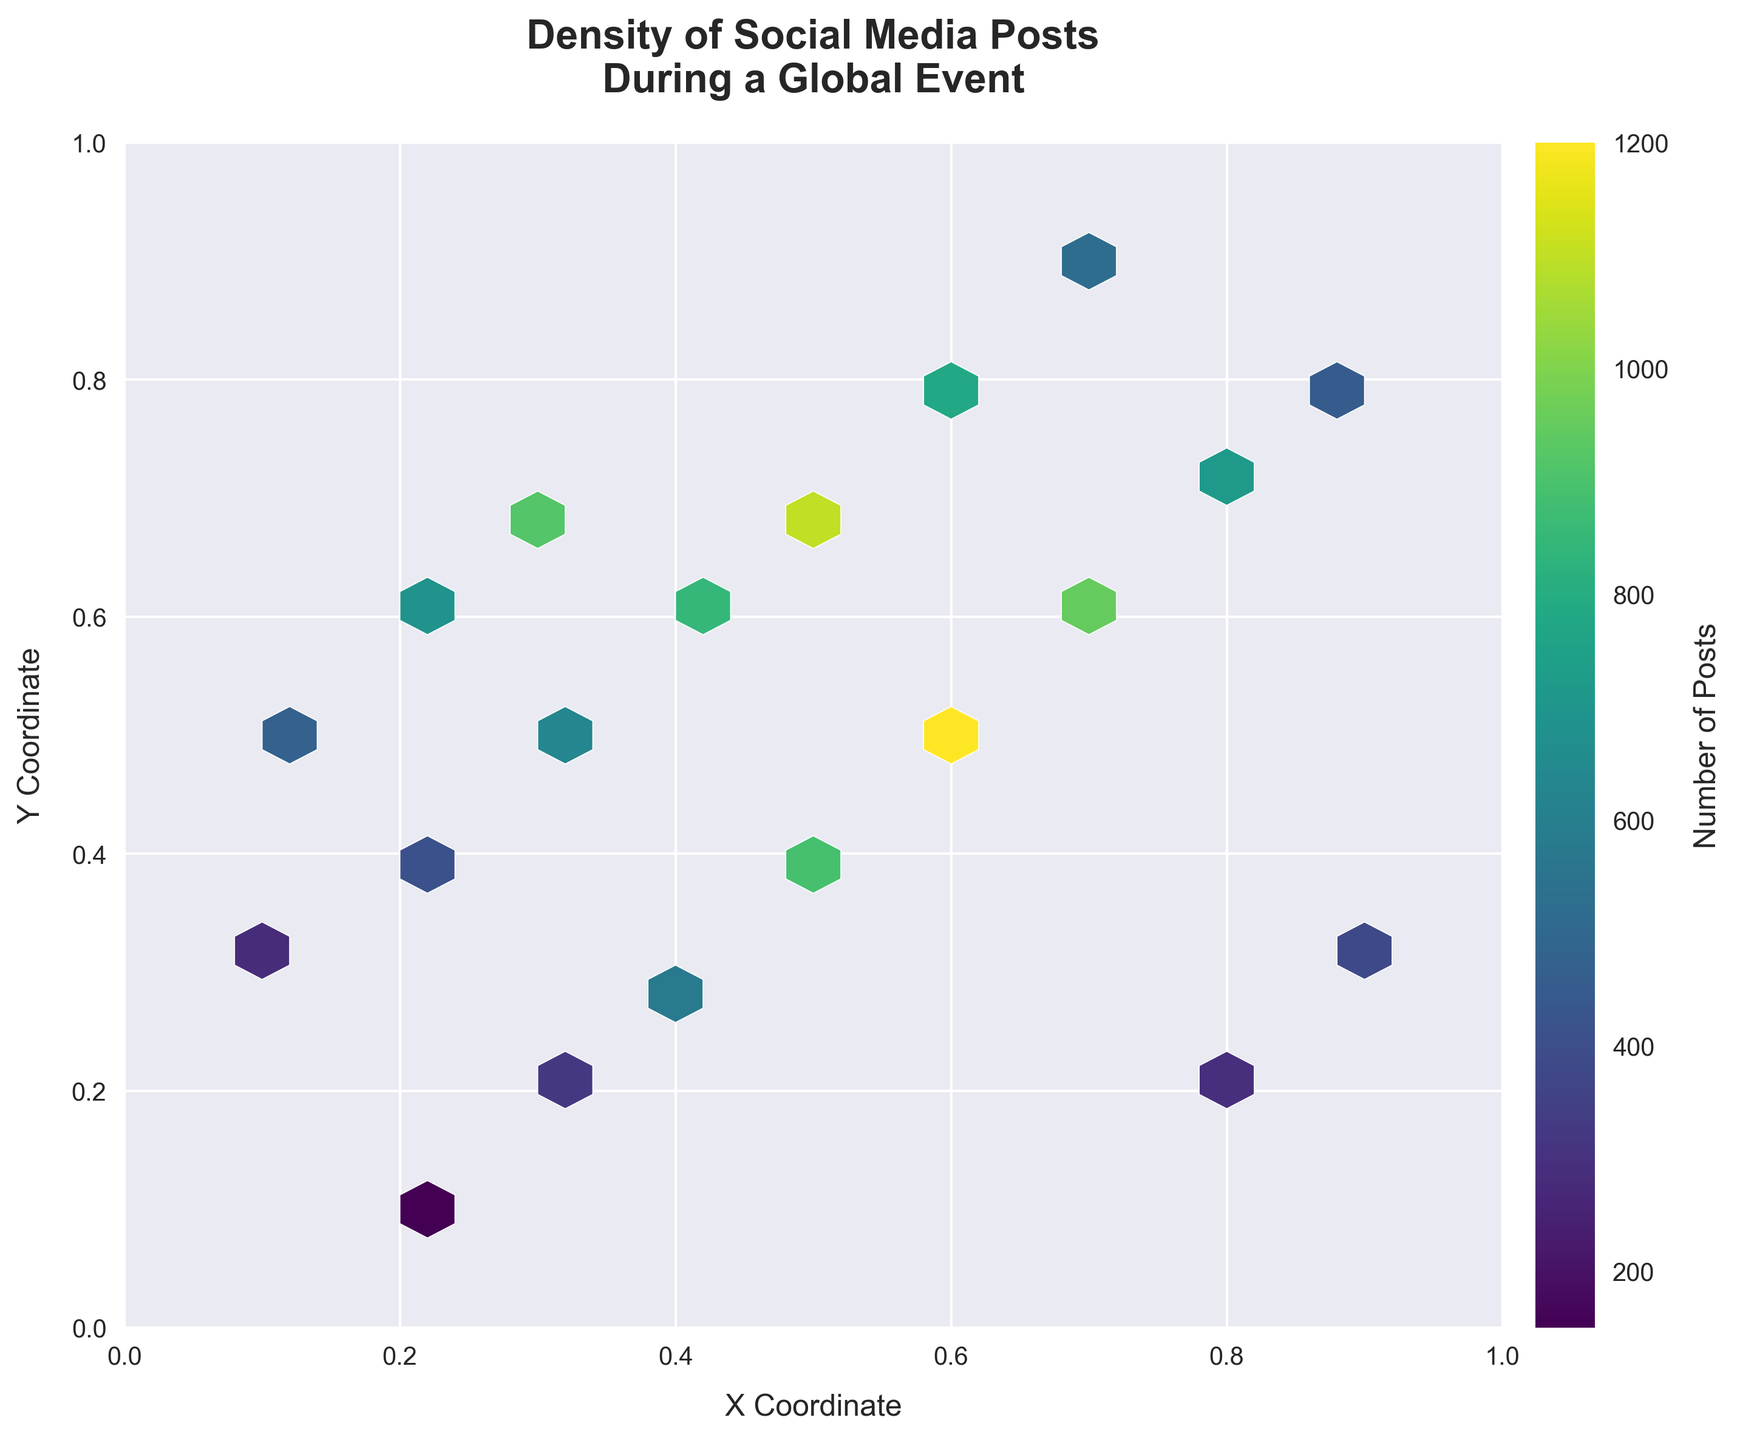What is the title of the plot? The title is the text at the top of the plot, usually summarizing the main point or context.
Answer: Density of Social Media Posts During a Global Event What do the x and y-axes represent? The labels on the x and y-axes explain what dimensions they represent. From the figure, they are labeled 'X Coordinate' and 'Y Coordinate'.
Answer: X Coordinate and Y Coordinate What does the color gradient represent in the hexbin plot? The color gradient shown in the plot usually represents the density or intensity of the data points. Darker or more intense colors typically indicate higher values. In this case, it represents the 'Number of Posts'.
Answer: Number of Posts What is the range of the x-axis? The x-axis limits can be read directly from the plot where it starts and ends. Here, it ranges from 0 to 1.
Answer: 0 to 1 Where are the highest densities of social media posts located in the plot? By observing the most intense colors on the plot, the location of highest densities of social media posts can be identified. The darkest areas are around the x=0.6, y=0.5 and x=0.6, y=0.8 coordinates.
Answer: Around x=0.6, y=0.5 and x=0.6, y=0.8 How many social media posts are there around the coordinates (0.4, 0.3)? Looking at the color corresponding to the coordinates (0.4, 0.3), we can identify the relative value of posts using the color bar. As per the figure, at (0.4, 0.3), the count is 580.
Answer: 580 What is the overall trend in the distribution of social media posts? By observing the color intensity and distribution pattern, we can see a trend where posts seem more concentrated around the middle region (0.4-0.8) of the plot.
Answer: Concentrated around the middle region Which hexbin has the second highest number of posts and what is the count? By comparing the color intensity of the hexagons and referred to color bar, the hexbin at coordinates (0.7, 0.6) is the second darkest, indicating it has the second highest count, which is around 950.
Answer: Coordinates (0.7, 0.6) with 950 posts What is the approximate range of post counts represented by the color gradient? Using the color bar scale on the plot, you can read the range of counts from the lightest to darkest color. The counts range approximately from 150 to 1200.
Answer: 150 to 1200 